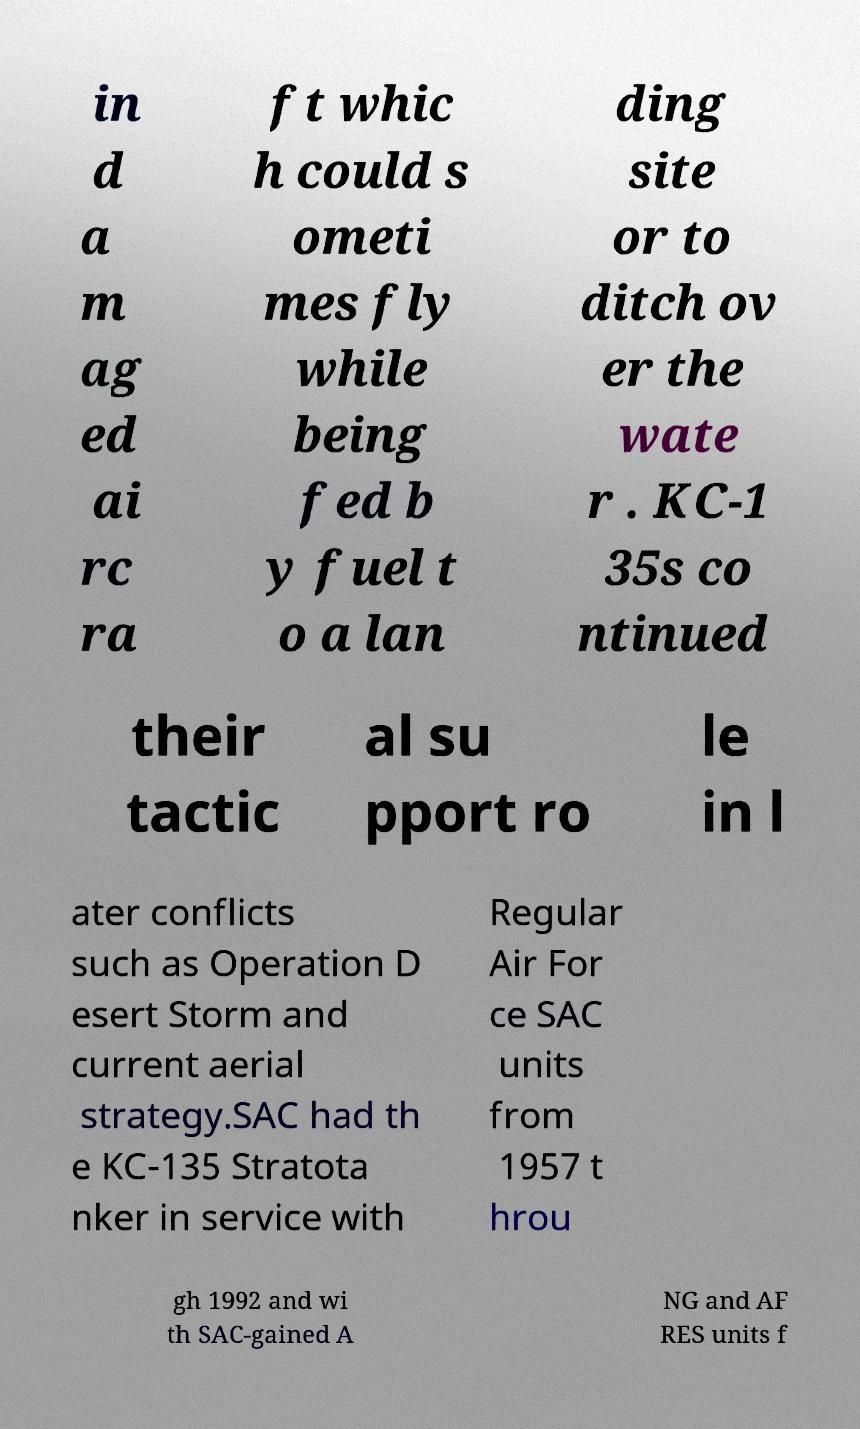For documentation purposes, I need the text within this image transcribed. Could you provide that? in d a m ag ed ai rc ra ft whic h could s ometi mes fly while being fed b y fuel t o a lan ding site or to ditch ov er the wate r . KC-1 35s co ntinued their tactic al su pport ro le in l ater conflicts such as Operation D esert Storm and current aerial strategy.SAC had th e KC-135 Stratota nker in service with Regular Air For ce SAC units from 1957 t hrou gh 1992 and wi th SAC-gained A NG and AF RES units f 